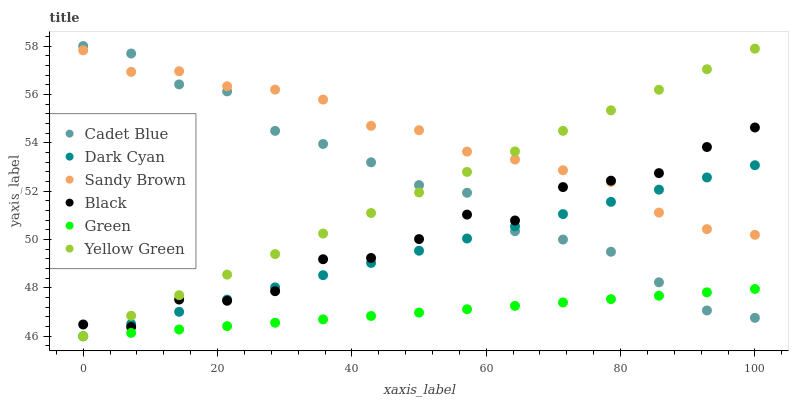Does Green have the minimum area under the curve?
Answer yes or no. Yes. Does Sandy Brown have the maximum area under the curve?
Answer yes or no. Yes. Does Yellow Green have the minimum area under the curve?
Answer yes or no. No. Does Yellow Green have the maximum area under the curve?
Answer yes or no. No. Is Green the smoothest?
Answer yes or no. Yes. Is Black the roughest?
Answer yes or no. Yes. Is Yellow Green the smoothest?
Answer yes or no. No. Is Yellow Green the roughest?
Answer yes or no. No. Does Yellow Green have the lowest value?
Answer yes or no. Yes. Does Black have the lowest value?
Answer yes or no. No. Does Cadet Blue have the highest value?
Answer yes or no. Yes. Does Yellow Green have the highest value?
Answer yes or no. No. Is Green less than Black?
Answer yes or no. Yes. Is Sandy Brown greater than Green?
Answer yes or no. Yes. Does Cadet Blue intersect Dark Cyan?
Answer yes or no. Yes. Is Cadet Blue less than Dark Cyan?
Answer yes or no. No. Is Cadet Blue greater than Dark Cyan?
Answer yes or no. No. Does Green intersect Black?
Answer yes or no. No. 